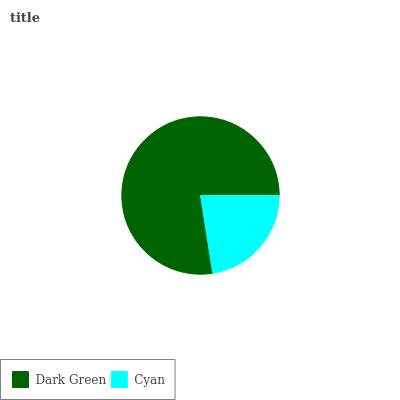Is Cyan the minimum?
Answer yes or no. Yes. Is Dark Green the maximum?
Answer yes or no. Yes. Is Cyan the maximum?
Answer yes or no. No. Is Dark Green greater than Cyan?
Answer yes or no. Yes. Is Cyan less than Dark Green?
Answer yes or no. Yes. Is Cyan greater than Dark Green?
Answer yes or no. No. Is Dark Green less than Cyan?
Answer yes or no. No. Is Dark Green the high median?
Answer yes or no. Yes. Is Cyan the low median?
Answer yes or no. Yes. Is Cyan the high median?
Answer yes or no. No. Is Dark Green the low median?
Answer yes or no. No. 